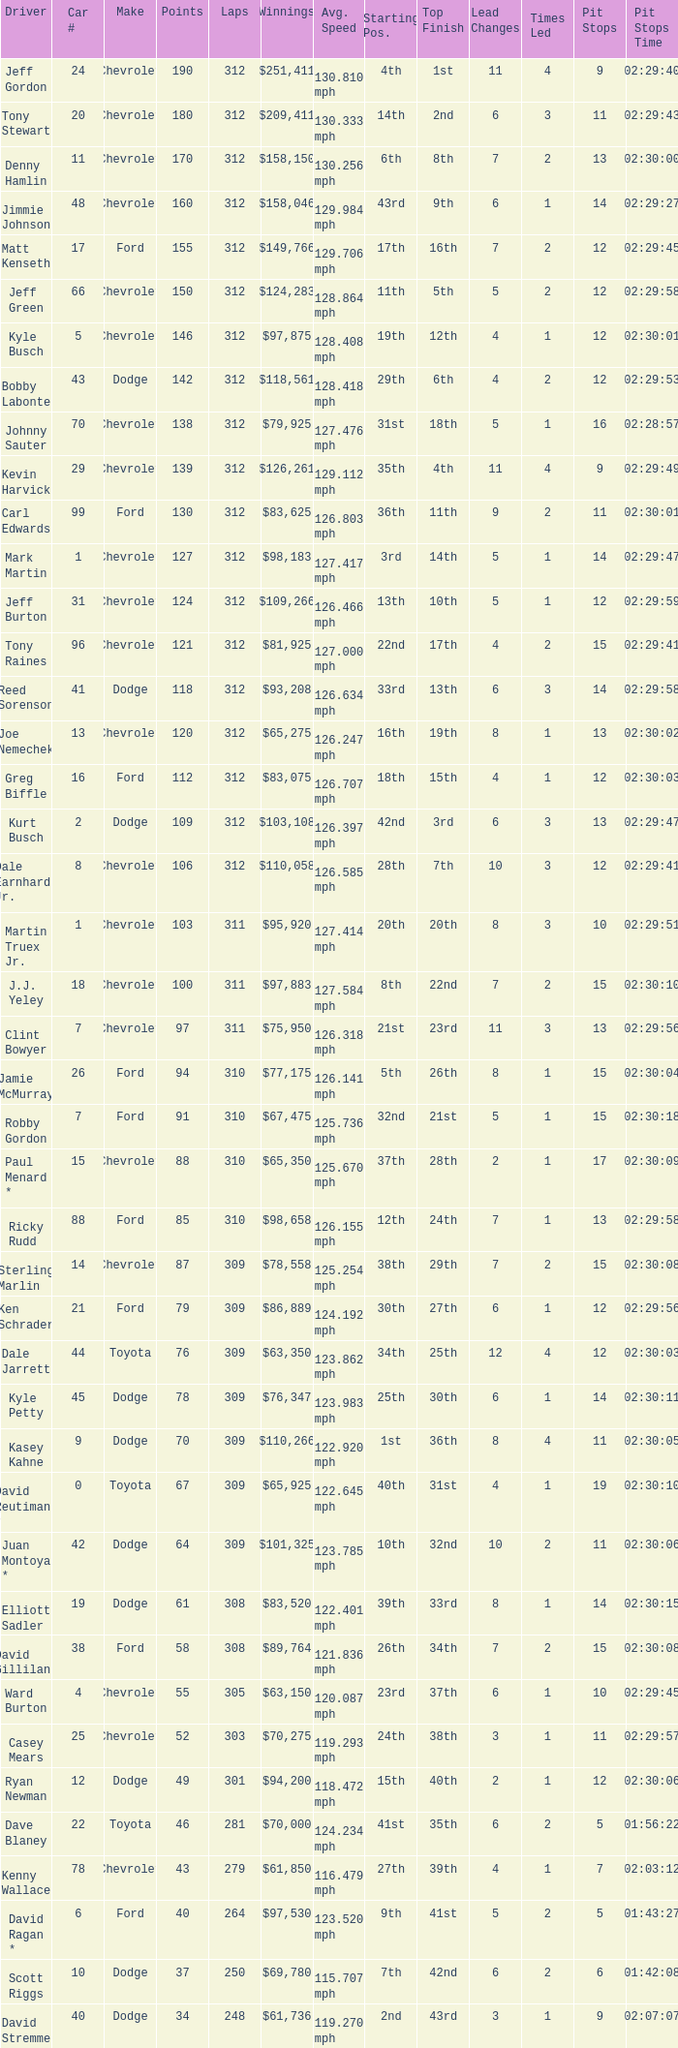What is the lowest number of laps for kyle petty with under 118 points? 309.0. 